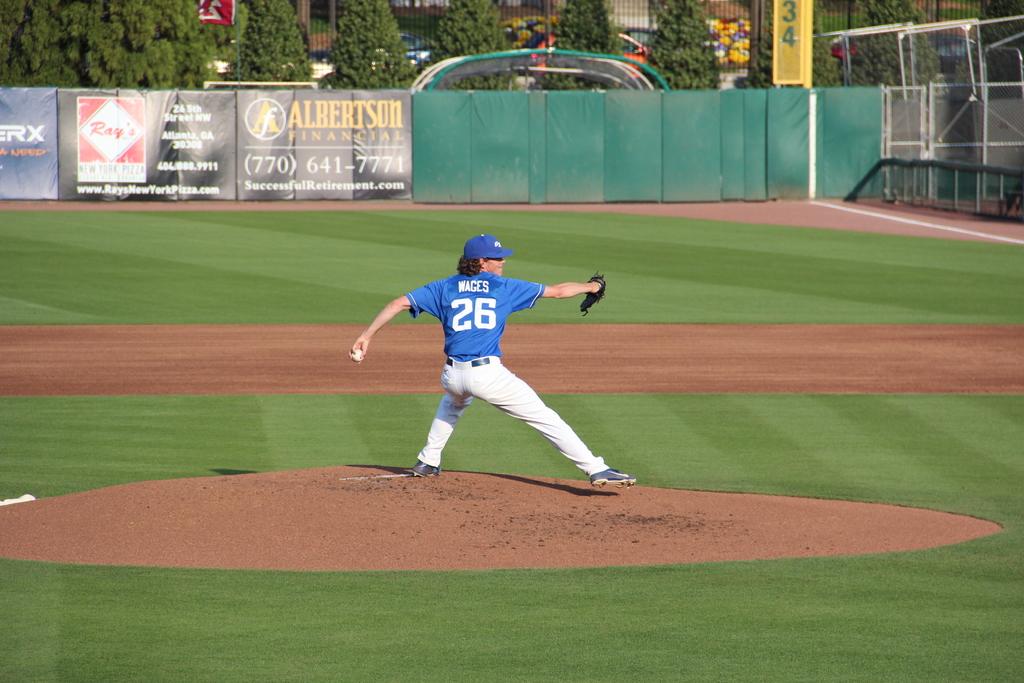What is the pitcher's name?
Offer a terse response. Wages. 